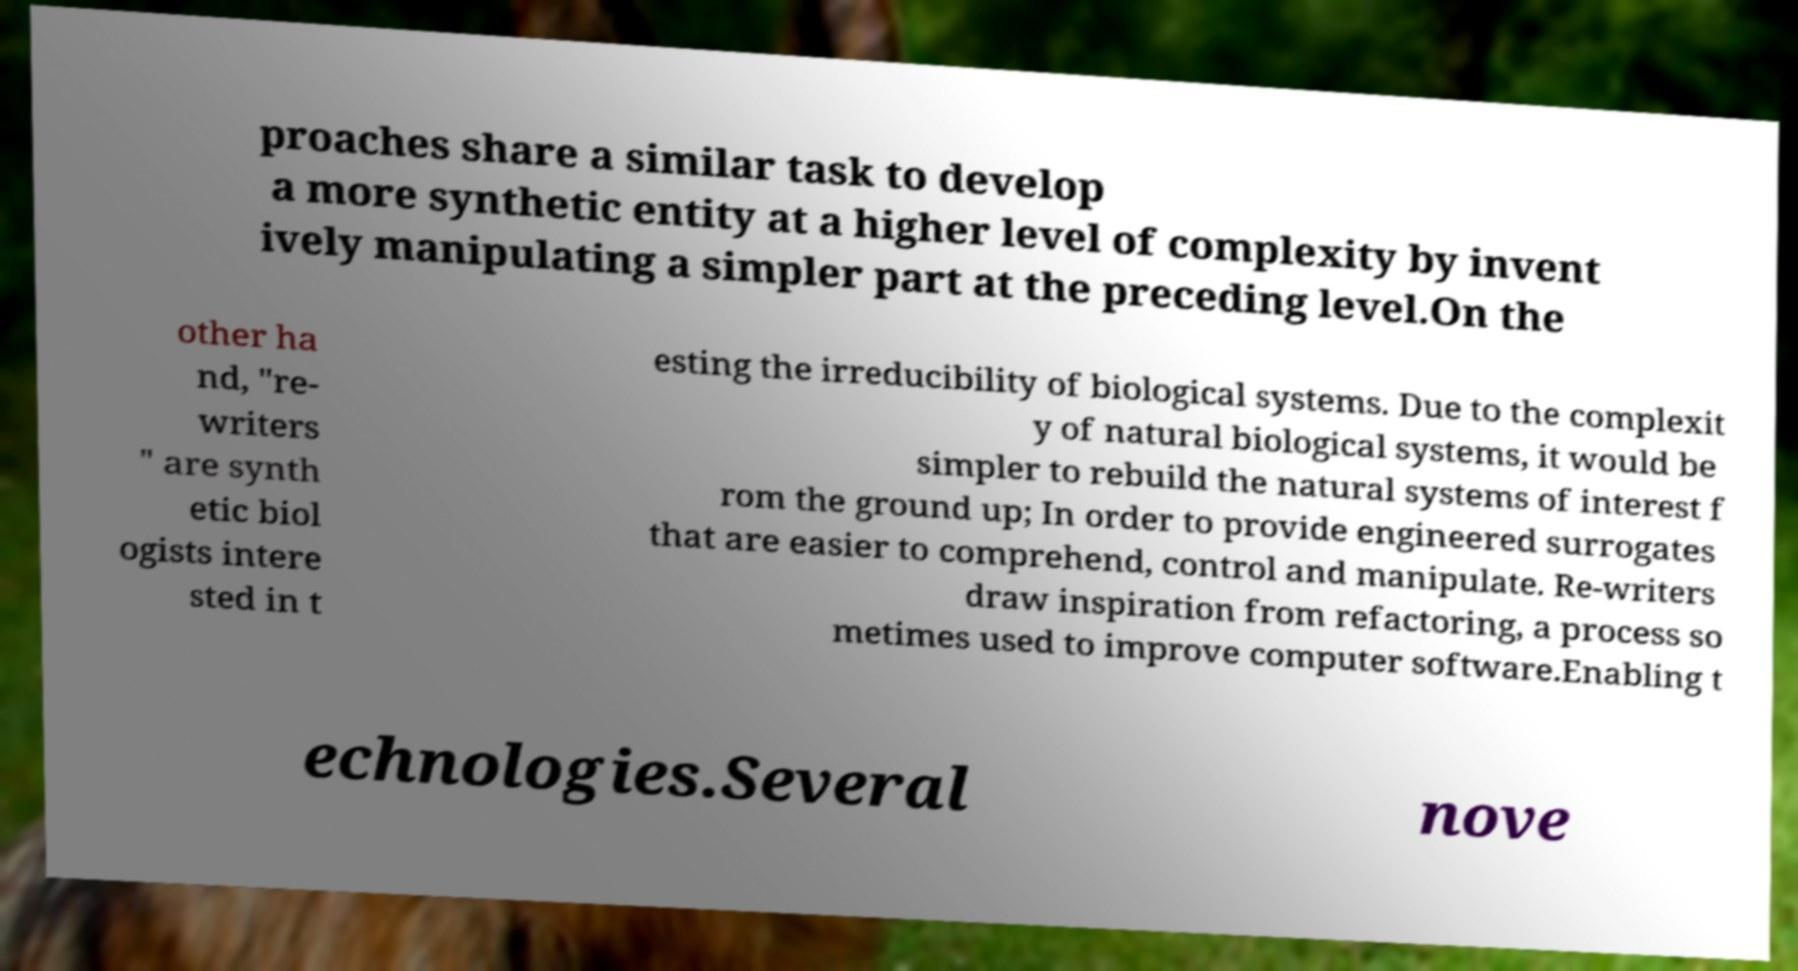What messages or text are displayed in this image? I need them in a readable, typed format. proaches share a similar task to develop a more synthetic entity at a higher level of complexity by invent ively manipulating a simpler part at the preceding level.On the other ha nd, "re- writers " are synth etic biol ogists intere sted in t esting the irreducibility of biological systems. Due to the complexit y of natural biological systems, it would be simpler to rebuild the natural systems of interest f rom the ground up; In order to provide engineered surrogates that are easier to comprehend, control and manipulate. Re-writers draw inspiration from refactoring, a process so metimes used to improve computer software.Enabling t echnologies.Several nove 